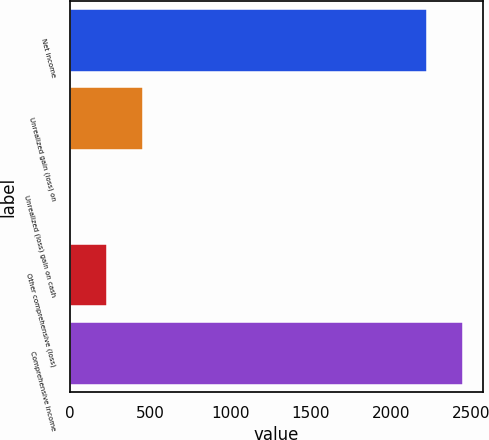<chart> <loc_0><loc_0><loc_500><loc_500><bar_chart><fcel>Net income<fcel>Unrealized gain (loss) on<fcel>Unrealized (loss) gain on cash<fcel>Other comprehensive (loss)<fcel>Comprehensive income<nl><fcel>2227<fcel>455.6<fcel>5<fcel>230.3<fcel>2452.3<nl></chart> 